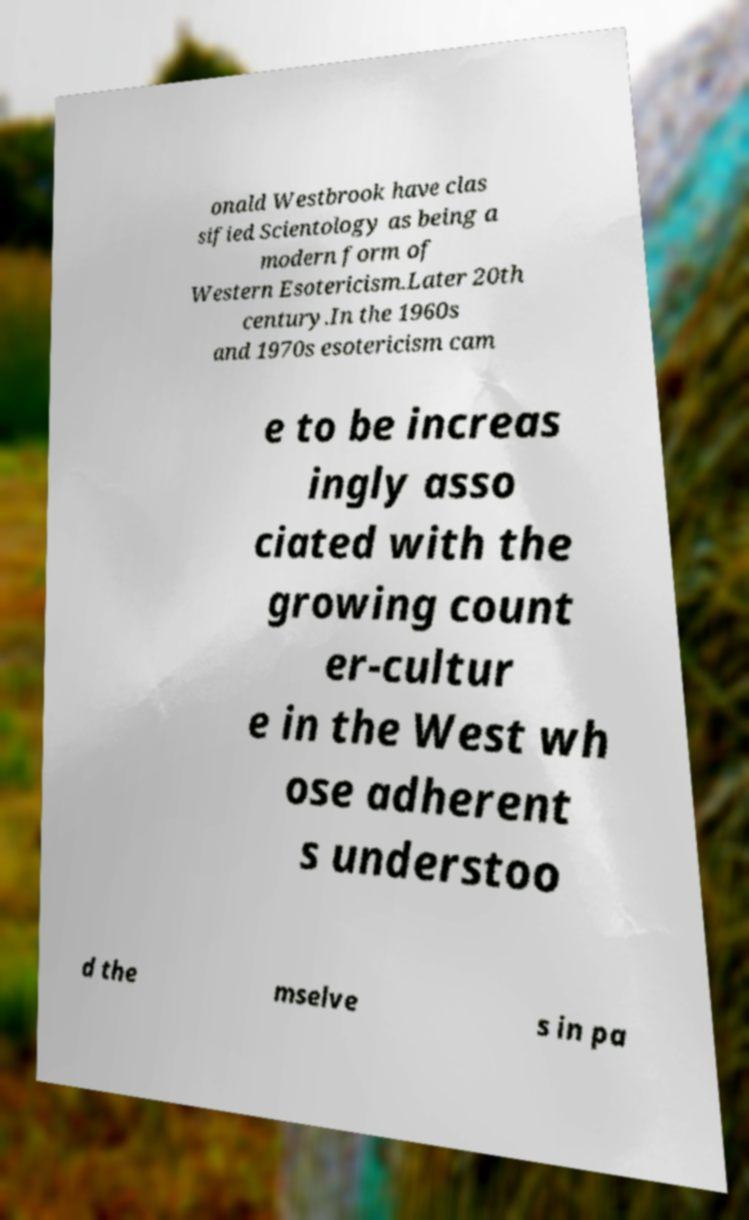Can you read and provide the text displayed in the image?This photo seems to have some interesting text. Can you extract and type it out for me? onald Westbrook have clas sified Scientology as being a modern form of Western Esotericism.Later 20th century.In the 1960s and 1970s esotericism cam e to be increas ingly asso ciated with the growing count er-cultur e in the West wh ose adherent s understoo d the mselve s in pa 